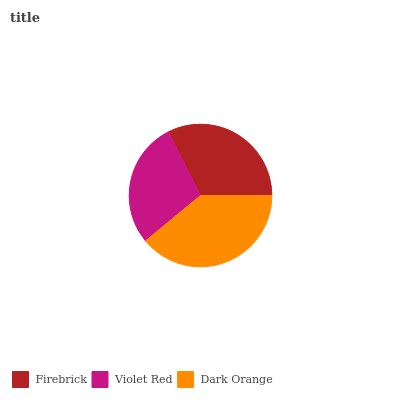Is Violet Red the minimum?
Answer yes or no. Yes. Is Dark Orange the maximum?
Answer yes or no. Yes. Is Dark Orange the minimum?
Answer yes or no. No. Is Violet Red the maximum?
Answer yes or no. No. Is Dark Orange greater than Violet Red?
Answer yes or no. Yes. Is Violet Red less than Dark Orange?
Answer yes or no. Yes. Is Violet Red greater than Dark Orange?
Answer yes or no. No. Is Dark Orange less than Violet Red?
Answer yes or no. No. Is Firebrick the high median?
Answer yes or no. Yes. Is Firebrick the low median?
Answer yes or no. Yes. Is Violet Red the high median?
Answer yes or no. No. Is Violet Red the low median?
Answer yes or no. No. 